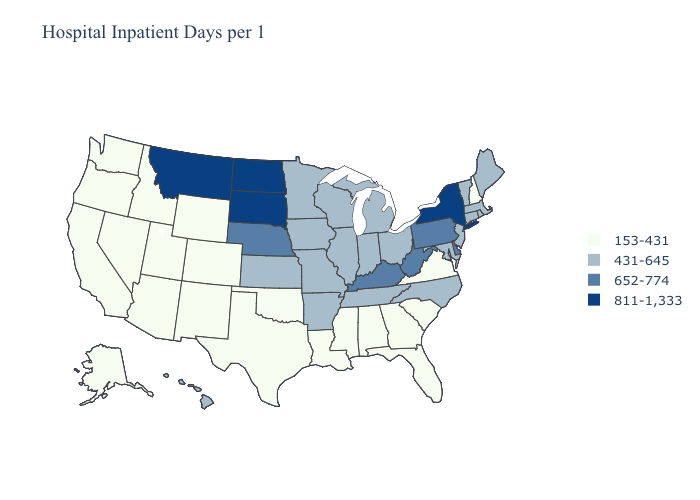Name the states that have a value in the range 652-774?
Give a very brief answer. Delaware, Kentucky, Nebraska, Pennsylvania, West Virginia. What is the highest value in states that border Kansas?
Quick response, please. 652-774. What is the highest value in the USA?
Short answer required. 811-1,333. Which states have the lowest value in the MidWest?
Keep it brief. Illinois, Indiana, Iowa, Kansas, Michigan, Minnesota, Missouri, Ohio, Wisconsin. How many symbols are there in the legend?
Keep it brief. 4. Which states have the lowest value in the USA?
Quick response, please. Alabama, Alaska, Arizona, California, Colorado, Florida, Georgia, Idaho, Louisiana, Mississippi, Nevada, New Hampshire, New Mexico, Oklahoma, Oregon, South Carolina, Texas, Utah, Virginia, Washington, Wyoming. Does New York have the highest value in the Northeast?
Give a very brief answer. Yes. What is the highest value in the USA?
Be succinct. 811-1,333. Name the states that have a value in the range 652-774?
Keep it brief. Delaware, Kentucky, Nebraska, Pennsylvania, West Virginia. How many symbols are there in the legend?
Answer briefly. 4. Does Hawaii have a higher value than Virginia?
Quick response, please. Yes. Name the states that have a value in the range 811-1,333?
Concise answer only. Montana, New York, North Dakota, South Dakota. Name the states that have a value in the range 153-431?
Answer briefly. Alabama, Alaska, Arizona, California, Colorado, Florida, Georgia, Idaho, Louisiana, Mississippi, Nevada, New Hampshire, New Mexico, Oklahoma, Oregon, South Carolina, Texas, Utah, Virginia, Washington, Wyoming. Name the states that have a value in the range 811-1,333?
Write a very short answer. Montana, New York, North Dakota, South Dakota. 